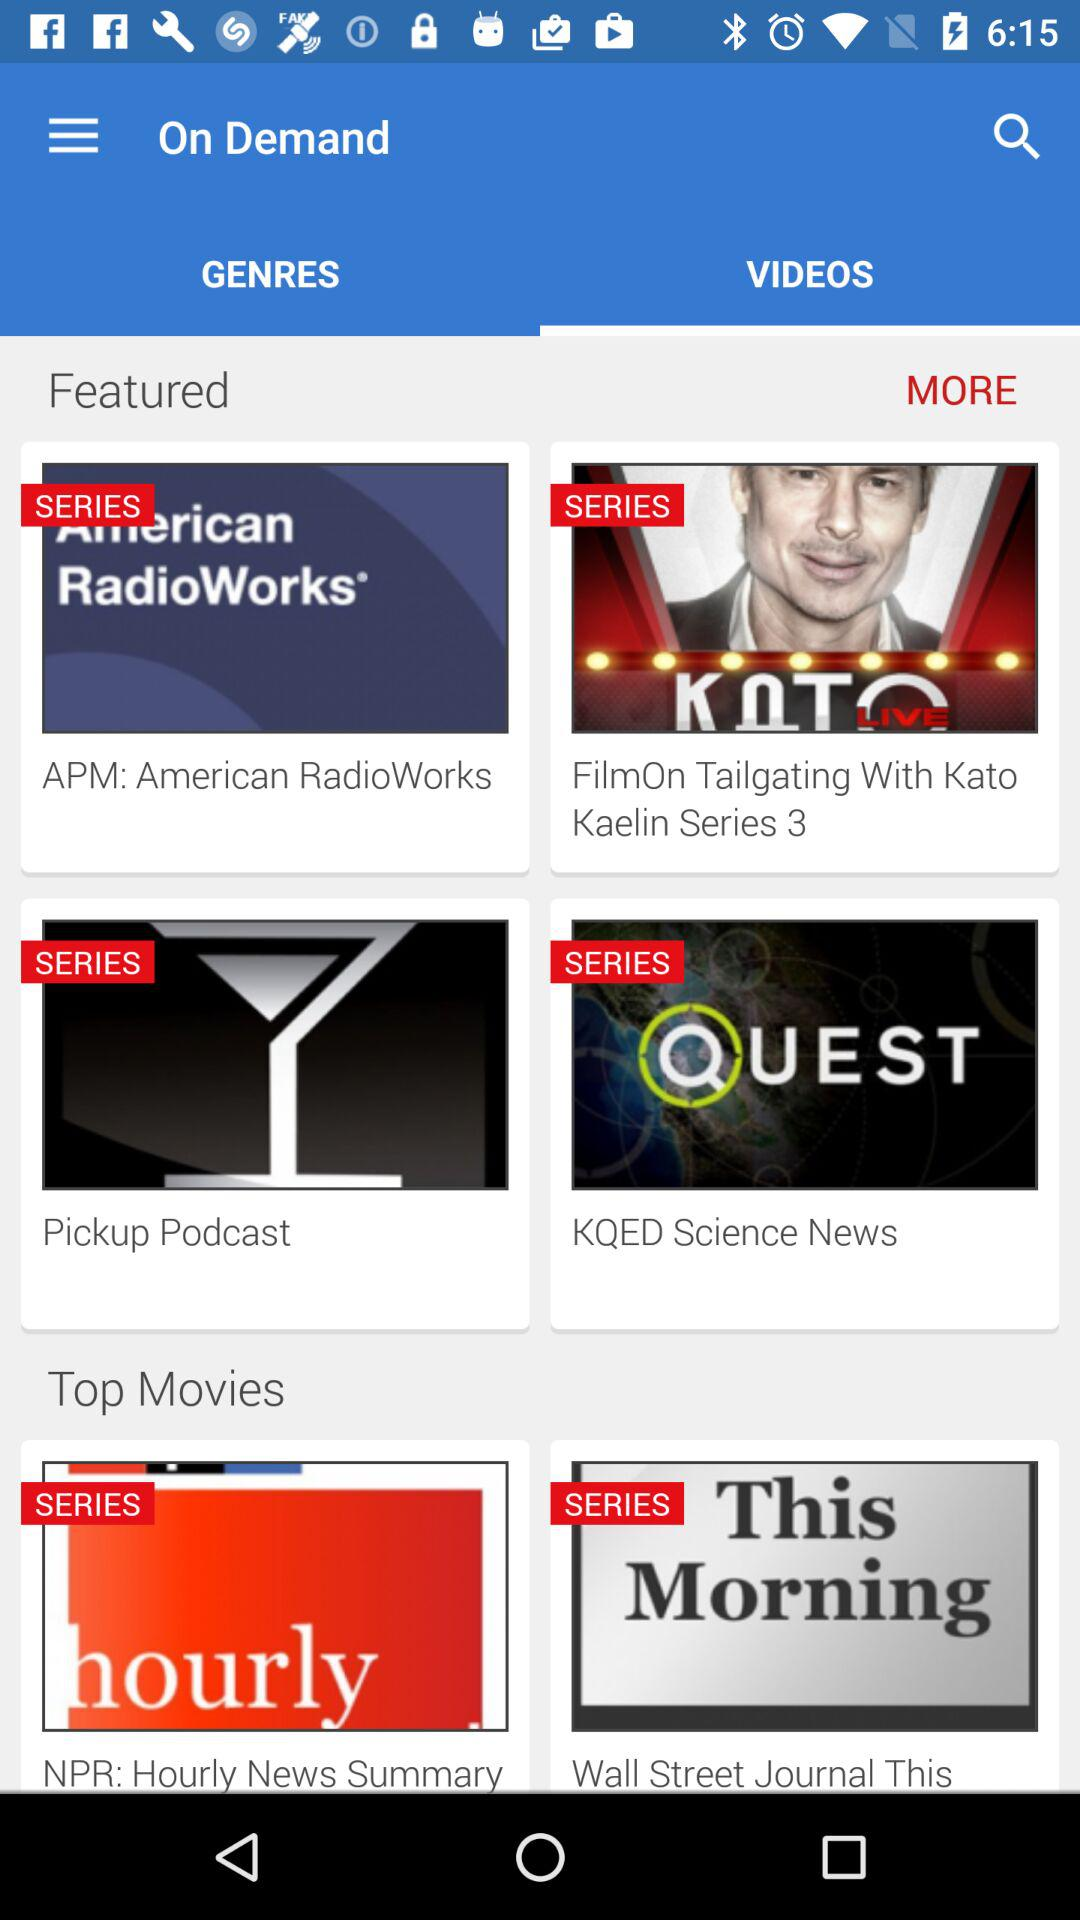Which option is selected in "On Demand"? The selected option is "VIDEOS". 